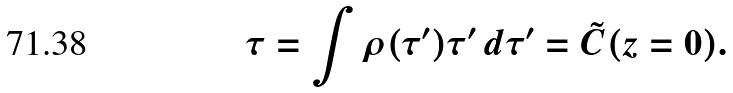<formula> <loc_0><loc_0><loc_500><loc_500>\tau = \int \rho ( \tau ^ { \prime } ) \tau ^ { \prime } \, d \tau ^ { \prime } = \tilde { C } ( z = 0 ) .</formula> 